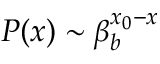Convert formula to latex. <formula><loc_0><loc_0><loc_500><loc_500>P ( x ) \sim \beta _ { b } ^ { x _ { 0 } - x }</formula> 